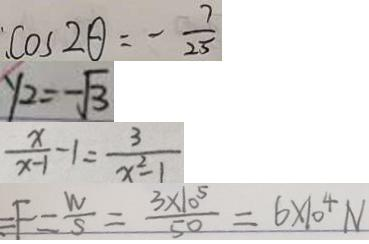Convert formula to latex. <formula><loc_0><loc_0><loc_500><loc_500>\cos 2 \theta = - \frac { 7 } { 2 5 } 
 y _ { 2 } = - \sqrt { 3 } 
 \frac { x } { x - 1 } - 1 = \frac { 3 } { x ^ { 2 } - 1 } 
 F = \frac { W } { S } = \frac { 3 \times 1 0 ^ { 5 } } { 5 0 } = 6 \times 1 0 ^ { 4 } N</formula> 